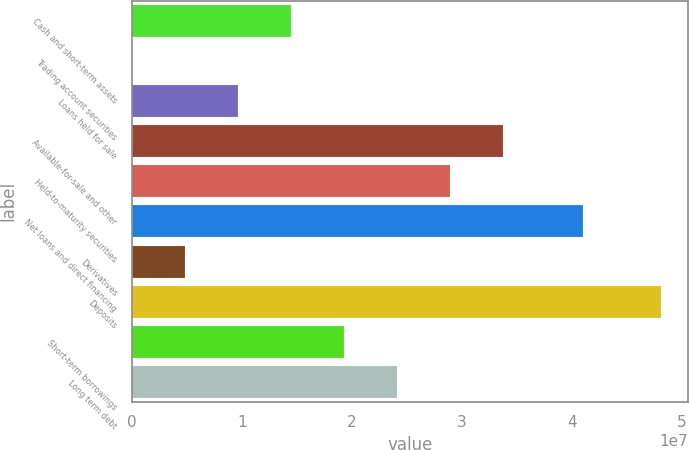Convert chart. <chart><loc_0><loc_0><loc_500><loc_500><bar_chart><fcel>Cash and short-term assets<fcel>Trading account securities<fcel>Loans held for sale<fcel>Available-for-sale and other<fcel>Held-to-maturity securities<fcel>Net loans and direct financing<fcel>Derivatives<fcel>Deposits<fcel>Short-term borrowings<fcel>Long term debt<nl><fcel>1.44647e+07<fcel>35573<fcel>9.65497e+06<fcel>3.37035e+07<fcel>2.88938e+07<fcel>4.0976e+07<fcel>4.84527e+06<fcel>4.81326e+07<fcel>1.92744e+07<fcel>2.40841e+07<nl></chart> 